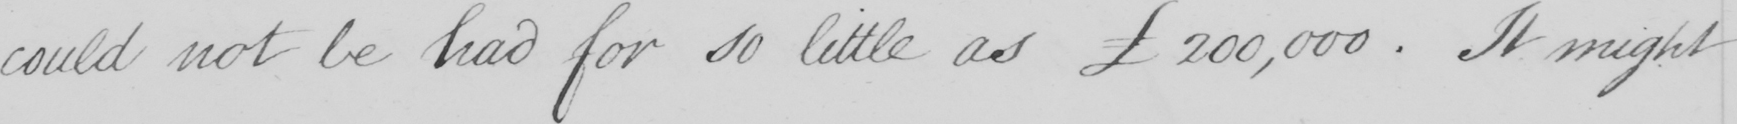Can you tell me what this handwritten text says? could not be had for so little as 200,000 . It might 